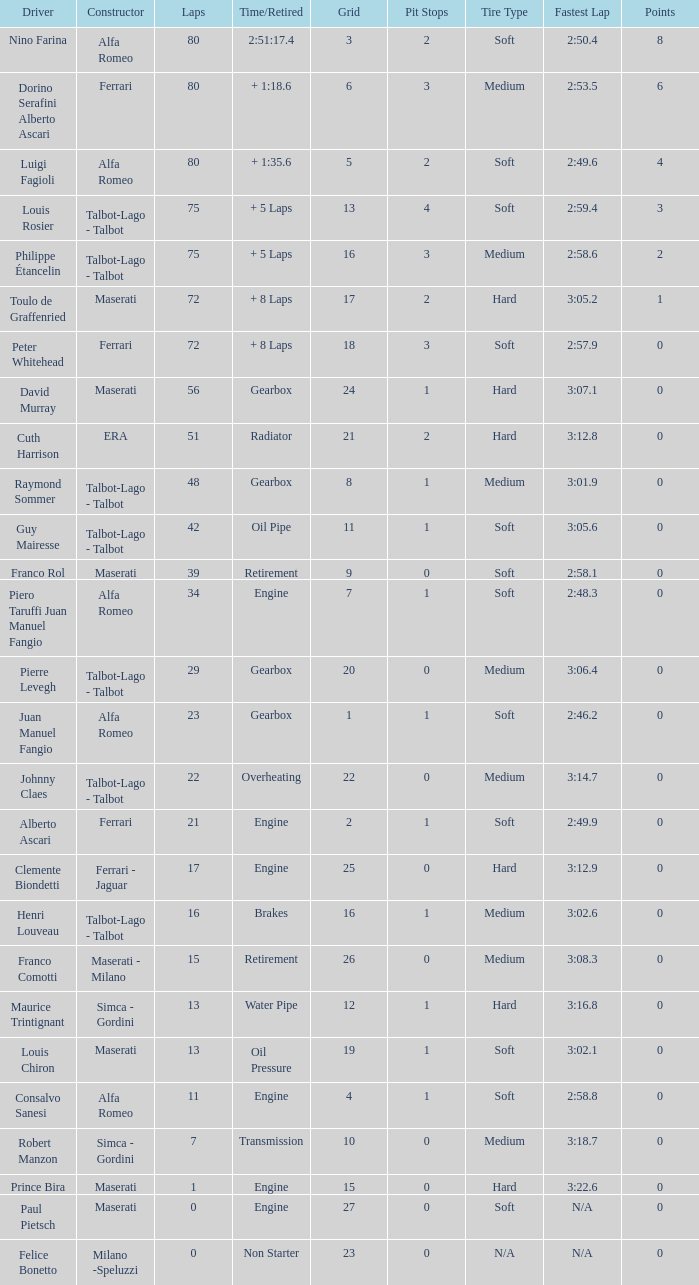When the driver is Juan Manuel Fangio and laps is less than 39, what is the highest grid? 1.0. 